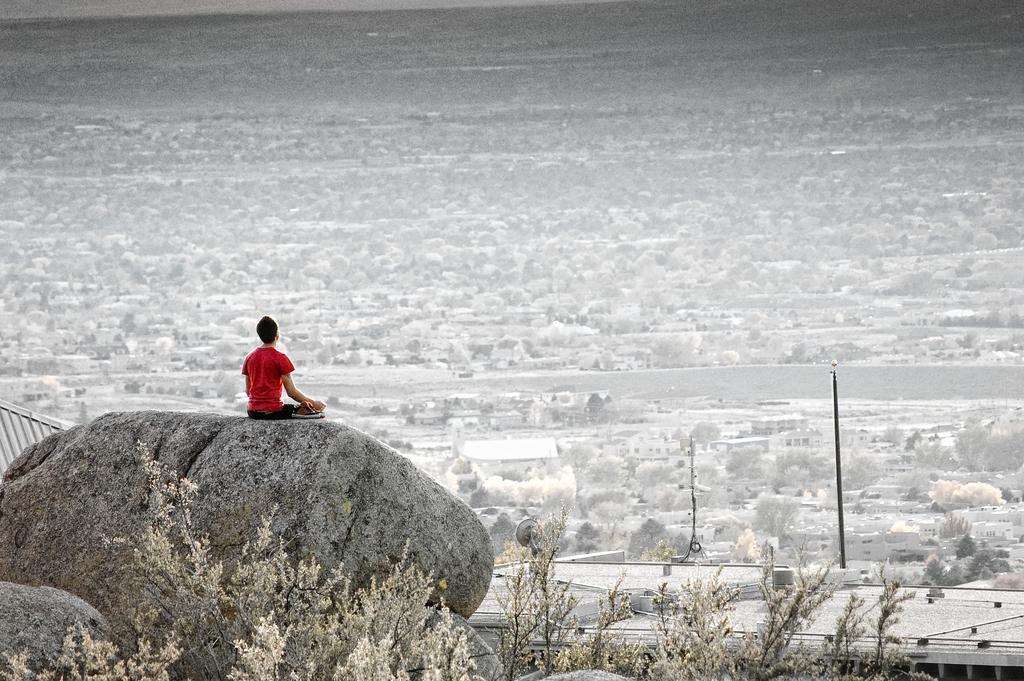Could you give a brief overview of what you see in this image? In this image in the front there are plants. In the center there is a stone and there is a person sitting on the stone. In the background there are houses and there are trees and there are poles. 